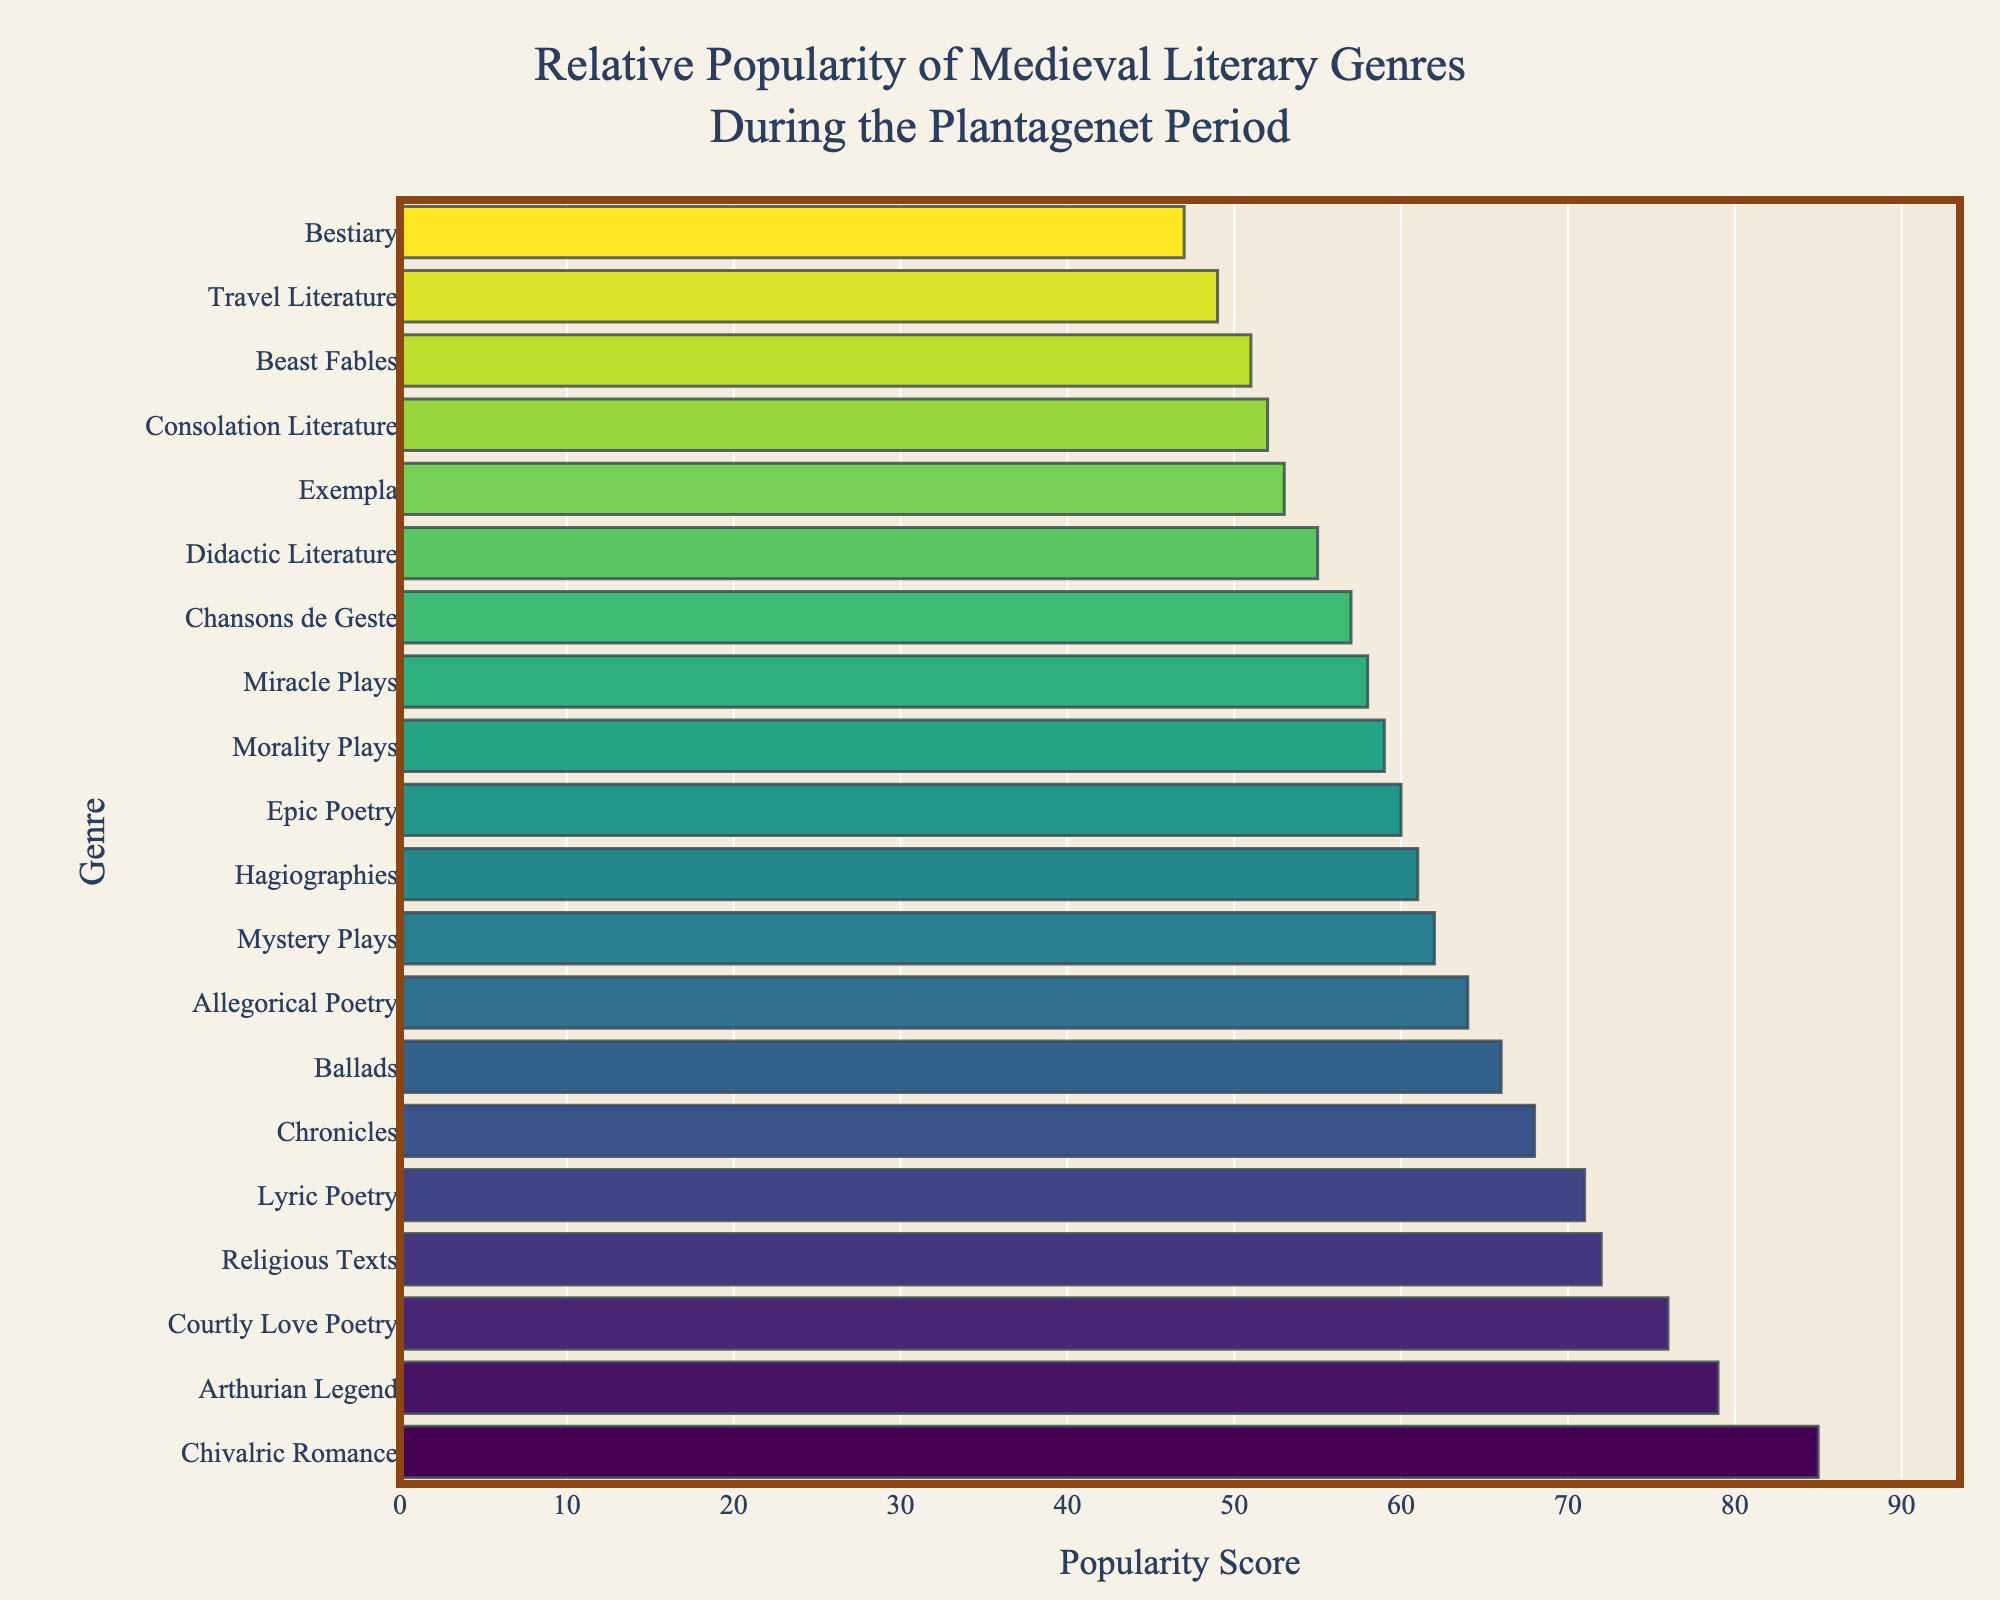Which genre has the highest popularity score? By examining the bar chart, the genre with the longest bar in the horizontal direction has the highest popularity score. Chivalric Romance has the longest bar.
Answer: Chivalric Romance Which genre has the lowest popularity score? By looking at the shortest bar in the horizontal direction, the genre with the lowest popularity score can be identified. Bestiary has the shortest bar.
Answer: Bestiary How do the popularity scores of Chivalric Romance and Arthurian Legend compare? Locate the bars for Chivalric Romance and Arthurian Legend. Chivalric Romance has a score of 85 and Arthurian Legend has a score of 79. Chivalric Romance's score is higher.
Answer: Chivalric Romance is higher What is the average popularity score of Chivalric Romance, Religious Texts, and Arthurian Legend? Add the scores of Chivalric Romance (85), Religious Texts (72), and Arthurian Legend (79), and then divide by the number of genres (3). (85 + 72 + 79) / 3 = 236 / 3 = 78.67.
Answer: 78.67 Which is more popular: Beast Fables or Miracle Plays? Compare the lengths of the bars for Beast Fables and Miracle Plays. Beast Fables has a score of 51 and Miracle Plays has a score of 58. Miracle Plays has a higher score.
Answer: Miracle Plays What is the sum of popularity scores for Hagiographies and Morality Plays? Add the popularity scores for Hagiographies (61) and Morality Plays (59). 61 + 59 = 120.
Answer: 120 How does the popularity of Epic Poetry compare to Ballads? Compare the lengths of the bars for Epic Poetry and Ballads. Epic Poetry has a score of 60 and Ballads has a score of 66. Ballads has the higher score.
Answer: Ballads is higher What's the range of popularity scores in the chart? Identify the highest and lowest popularity scores. The highest score is for Chivalric Romance (85), and the lowest is for Bestiary (47). Subtract the lowest score from the highest score. 85 - 47 = 38.
Answer: 38 How many genres have a popularity score greater than 70? Count the bars which have their scores greater than 70. These genres are Chivalric Romance (85), Religious Texts (72), Arthurian Legend (79), Courtly Love Poetry (76), and Lyric Poetry (71). There are 5 genres.
Answer: 5 Which genres have a popularity score exactly in the middle of the highest (85) and lowest (47) scores? Calculate the midpoint between the highest and lowest scores: (85 + 47) / 2 = 66. The genres with exactly 66 score are Chronicles and Ballads.
Answer: Chronicles and Ballads 